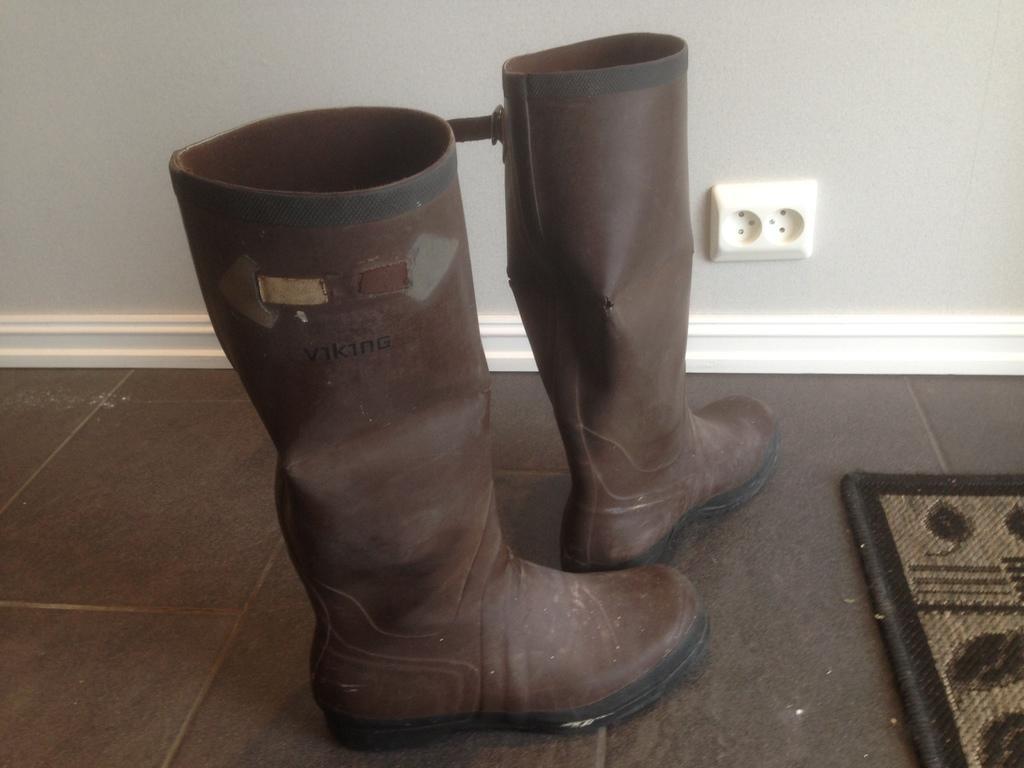Please provide a concise description of this image. In this image we can see riding boots, it is in brown color, here is the wall. 